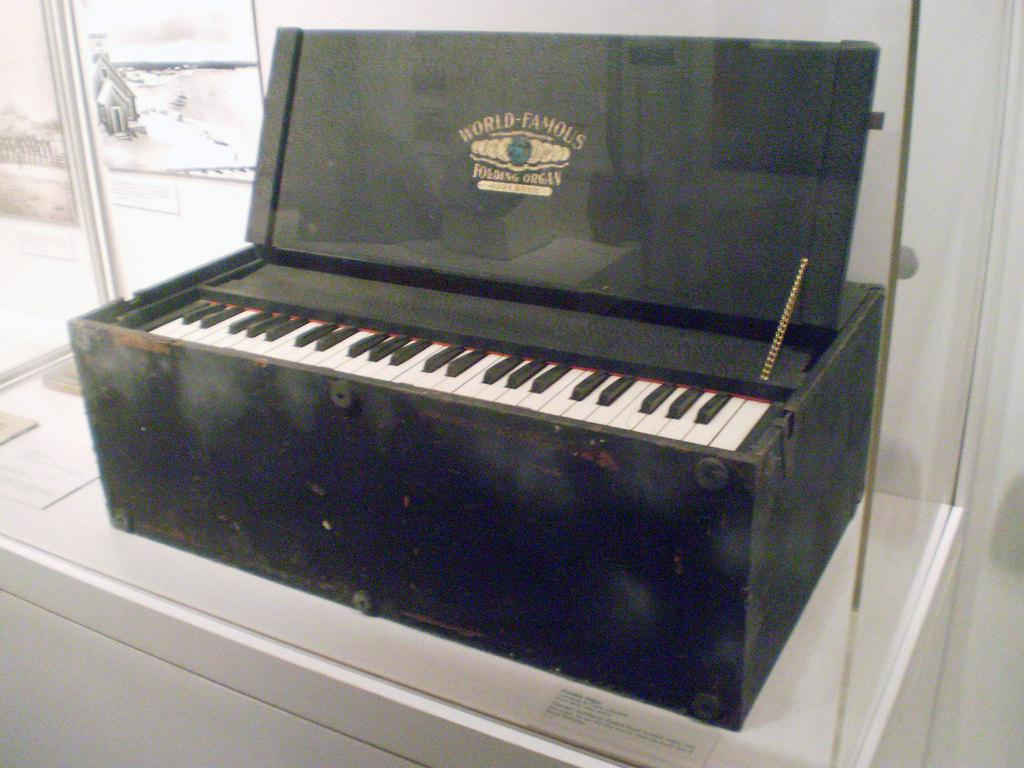What is present on the table in the image? There is a harmonium on the table in the image. What material is the harmonium made of? The harmonium is made of wood. What can be seen in the background of the image? There is a glass door visible in the background of the image. What type of soda is being served in the image? There is no soda present in the image; it features a wooden harmonium on a table and a glass door in the background. Is there any oatmeal visible in the image? There is no oatmeal present in the image. 